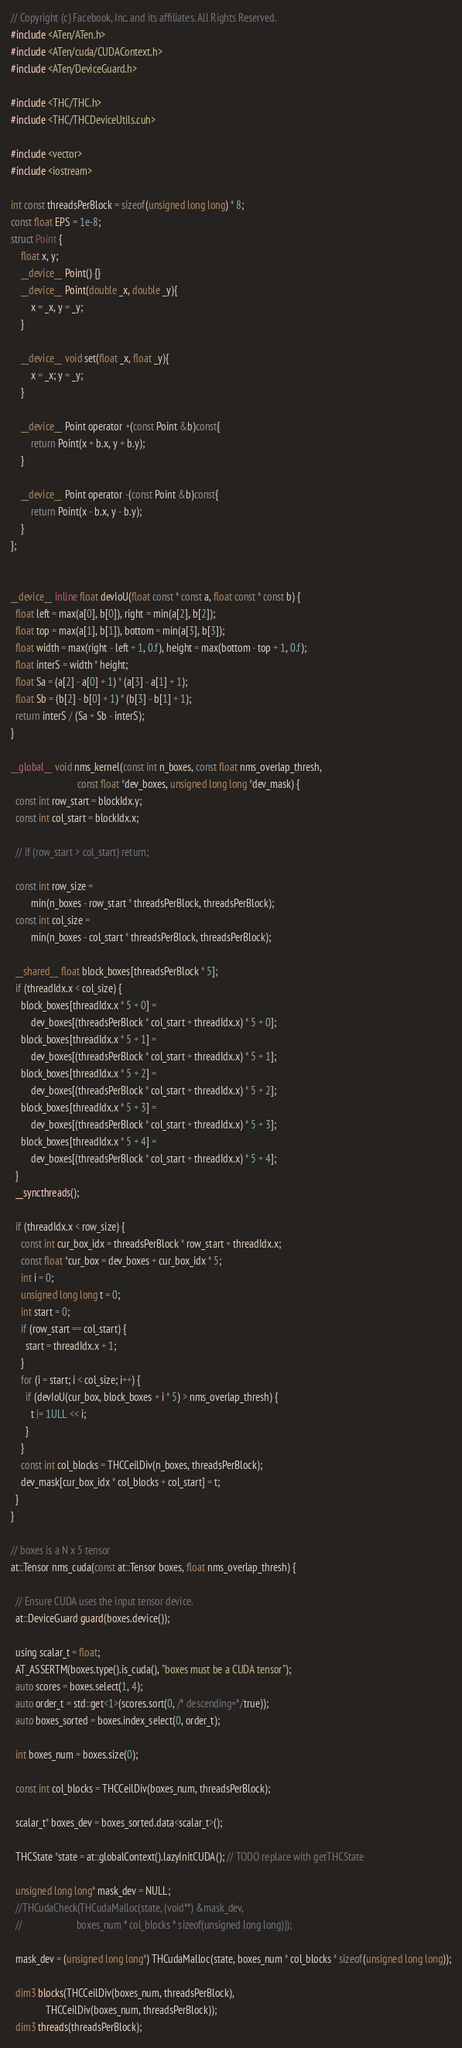<code> <loc_0><loc_0><loc_500><loc_500><_Cuda_>// Copyright (c) Facebook, Inc. and its affiliates. All Rights Reserved.
#include <ATen/ATen.h>
#include <ATen/cuda/CUDAContext.h>
#include <ATen/DeviceGuard.h>

#include <THC/THC.h>
#include <THC/THCDeviceUtils.cuh>

#include <vector>
#include <iostream>

int const threadsPerBlock = sizeof(unsigned long long) * 8;
const float EPS = 1e-8;
struct Point {
    float x, y;
    __device__ Point() {}
    __device__ Point(double _x, double _y){
        x = _x, y = _y;
    }

    __device__ void set(float _x, float _y){
        x = _x; y = _y;
    }

    __device__ Point operator +(const Point &b)const{
        return Point(x + b.x, y + b.y);
    }

    __device__ Point operator -(const Point &b)const{
        return Point(x - b.x, y - b.y);
    }
};


__device__ inline float devIoU(float const * const a, float const * const b) {
  float left = max(a[0], b[0]), right = min(a[2], b[2]);
  float top = max(a[1], b[1]), bottom = min(a[3], b[3]);
  float width = max(right - left + 1, 0.f), height = max(bottom - top + 1, 0.f);
  float interS = width * height;
  float Sa = (a[2] - a[0] + 1) * (a[3] - a[1] + 1);
  float Sb = (b[2] - b[0] + 1) * (b[3] - b[1] + 1);
  return interS / (Sa + Sb - interS);
}

__global__ void nms_kernel(const int n_boxes, const float nms_overlap_thresh,
                           const float *dev_boxes, unsigned long long *dev_mask) {
  const int row_start = blockIdx.y;
  const int col_start = blockIdx.x;

  // if (row_start > col_start) return;

  const int row_size =
        min(n_boxes - row_start * threadsPerBlock, threadsPerBlock);
  const int col_size =
        min(n_boxes - col_start * threadsPerBlock, threadsPerBlock);

  __shared__ float block_boxes[threadsPerBlock * 5];
  if (threadIdx.x < col_size) {
    block_boxes[threadIdx.x * 5 + 0] =
        dev_boxes[(threadsPerBlock * col_start + threadIdx.x) * 5 + 0];
    block_boxes[threadIdx.x * 5 + 1] =
        dev_boxes[(threadsPerBlock * col_start + threadIdx.x) * 5 + 1];
    block_boxes[threadIdx.x * 5 + 2] =
        dev_boxes[(threadsPerBlock * col_start + threadIdx.x) * 5 + 2];
    block_boxes[threadIdx.x * 5 + 3] =
        dev_boxes[(threadsPerBlock * col_start + threadIdx.x) * 5 + 3];
    block_boxes[threadIdx.x * 5 + 4] =
        dev_boxes[(threadsPerBlock * col_start + threadIdx.x) * 5 + 4];
  }
  __syncthreads();

  if (threadIdx.x < row_size) {
    const int cur_box_idx = threadsPerBlock * row_start + threadIdx.x;
    const float *cur_box = dev_boxes + cur_box_idx * 5;
    int i = 0;
    unsigned long long t = 0;
    int start = 0;
    if (row_start == col_start) {
      start = threadIdx.x + 1;
    }
    for (i = start; i < col_size; i++) {
      if (devIoU(cur_box, block_boxes + i * 5) > nms_overlap_thresh) {
        t |= 1ULL << i;
      }
    }
    const int col_blocks = THCCeilDiv(n_boxes, threadsPerBlock);
    dev_mask[cur_box_idx * col_blocks + col_start] = t;
  }
}

// boxes is a N x 5 tensor
at::Tensor nms_cuda(const at::Tensor boxes, float nms_overlap_thresh) {

  // Ensure CUDA uses the input tensor device.
  at::DeviceGuard guard(boxes.device());

  using scalar_t = float;
  AT_ASSERTM(boxes.type().is_cuda(), "boxes must be a CUDA tensor");
  auto scores = boxes.select(1, 4);
  auto order_t = std::get<1>(scores.sort(0, /* descending=*/true));
  auto boxes_sorted = boxes.index_select(0, order_t);

  int boxes_num = boxes.size(0);

  const int col_blocks = THCCeilDiv(boxes_num, threadsPerBlock);

  scalar_t* boxes_dev = boxes_sorted.data<scalar_t>();

  THCState *state = at::globalContext().lazyInitCUDA(); // TODO replace with getTHCState

  unsigned long long* mask_dev = NULL;
  //THCudaCheck(THCudaMalloc(state, (void**) &mask_dev,
  //                      boxes_num * col_blocks * sizeof(unsigned long long)));

  mask_dev = (unsigned long long*) THCudaMalloc(state, boxes_num * col_blocks * sizeof(unsigned long long));

  dim3 blocks(THCCeilDiv(boxes_num, threadsPerBlock),
              THCCeilDiv(boxes_num, threadsPerBlock));
  dim3 threads(threadsPerBlock);</code> 